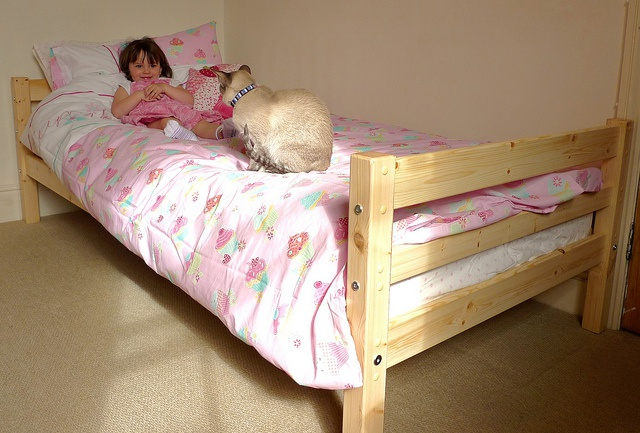Describe the objects in this image and their specific colors. I can see bed in gray, white, darkgray, and tan tones, cat in gray, tan, and beige tones, and people in gray, brown, black, darkgray, and maroon tones in this image. 